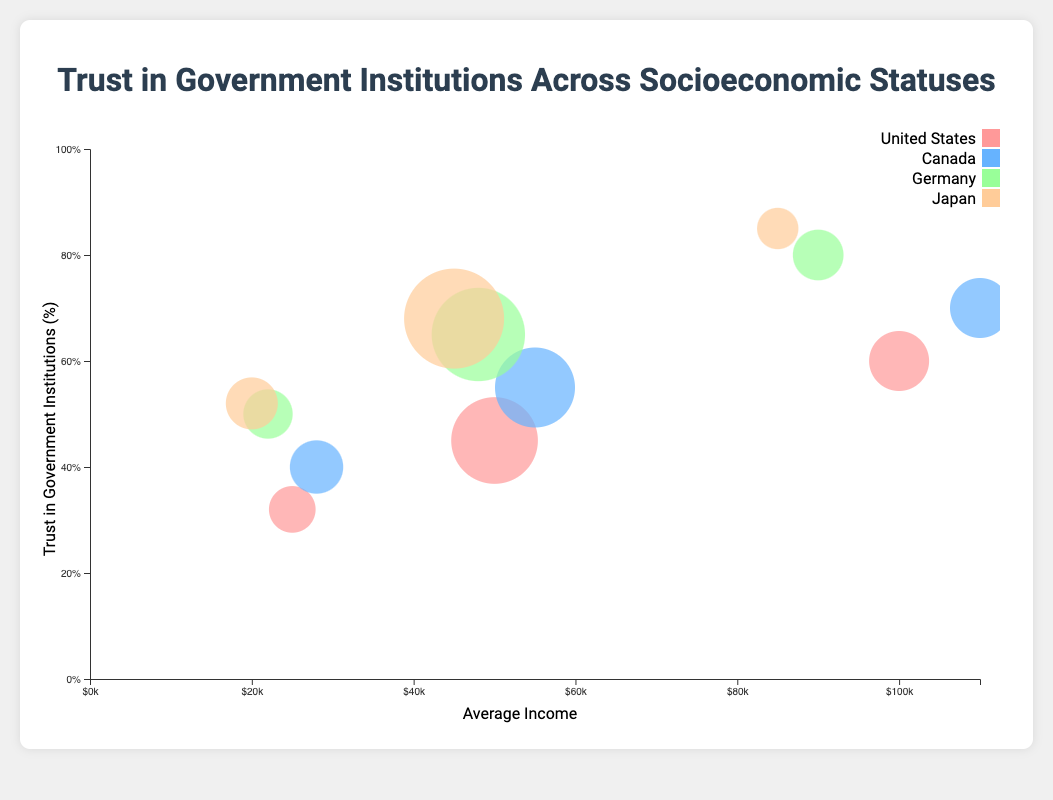What's the title of the chart? The title is located at the top center of the chart.
Answer: Trust in Government Institutions Across Socioeconomic Statuses What does the x-axis represent? The x-axis label is provided along the bottom of the chart.
Answer: Average Income What does the y-axis represent? The y-axis label is positioned in a rotated manner along the left side of the chart.
Answer: Trust in Government Institutions (%) Which country has the highest trust in government institutions among high socioeconomic status? Identify the highest trust percentage among high socioeconomic status and the country associated with it.
Answer: Japan Compare the trust in government institutions between low and high socioeconomic status in the United States. Locate the United States bubbles, note the trust percentages for low and high socioeconomic statuses, and compare them.
Answer: Low: 32%, High: 60% What is the range of average incomes for the bubbles plotted? Check the minimum and maximum average income values from the plotted bubbles along the x-axis.
Answer: $20k to $110k Which country's middle socioeconomic status has the highest population percentage? Find the middle socioeconomic status bubbles for each country and compare their population percentages.
Answer: Japan What is the relationship between average income and trust in government within Germany? Observe the trend of trust percentages with respect to increasing average income for Germany.
Answer: Increasing How does the population percentage affect the size of bubbles in the chart? Observe different bubbles and notice how their sizes correspond to their population percentages.
Answer: Larger population percentage = Larger bubble size Which country shows the smallest range in trust in government institutions among different socioeconomic statuses? Compare the ranges (difference between highest and lowest) of trust percentages among all socioeconomic statuses for each country.
Answer: United States 